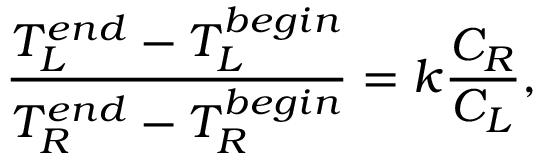Convert formula to latex. <formula><loc_0><loc_0><loc_500><loc_500>\frac { T _ { L } ^ { e n d } - T _ { L } ^ { b e g i n } } { T _ { R } ^ { e n d } - T _ { R } ^ { b e g i n } } = k \frac { C _ { R } } { C _ { L } } ,</formula> 